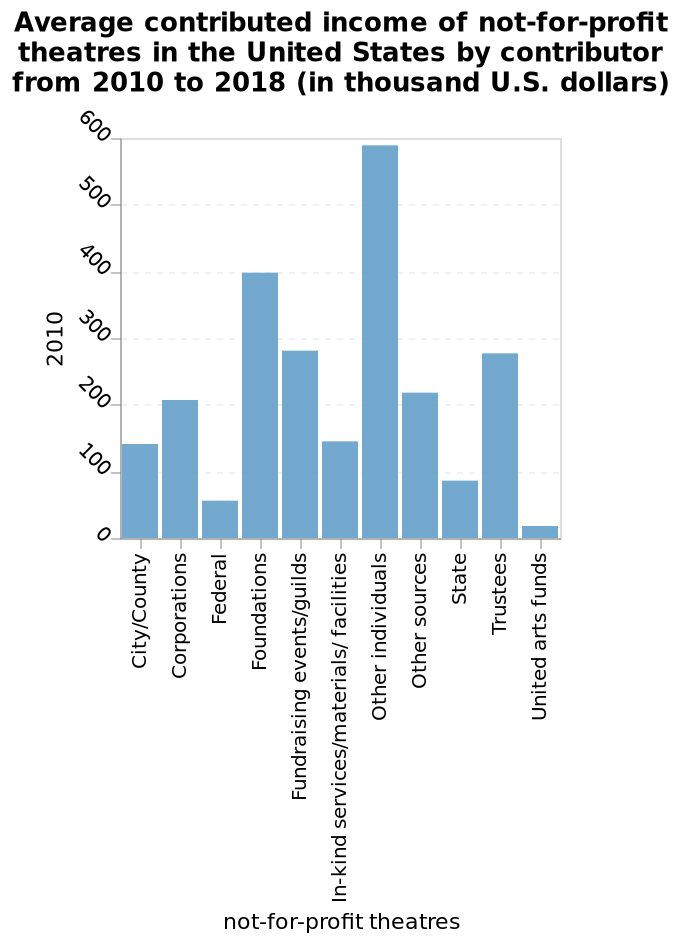<image>
Which category of donors had the biggest average contributions? Corporations, Foundations, and other individuals. Who had the largest contributions on average?  Corporations, Foundations, and other individuals. 